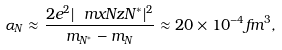Convert formula to latex. <formula><loc_0><loc_0><loc_500><loc_500>\alpha _ { N } \approx \frac { 2 e ^ { 2 } | \ m x { N } { z } { N ^ { \ast } } | ^ { 2 } } { m _ { N ^ { \ast } } - m _ { N } } \approx 2 0 \times 1 0 ^ { - 4 } f m ^ { 3 } ,</formula> 